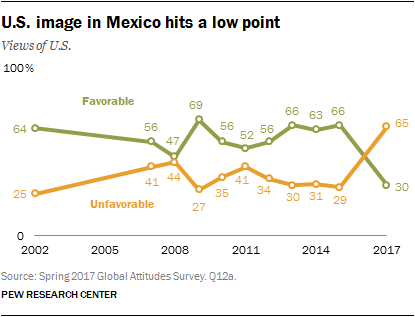What does the source tell us about this data, and how might this affect our interpretation? The source, which is the Spring 2017 Global Attitudes Survey by Pew Research Center, suggests that the data is collected through a survey method which captures the attitudes of a sample of the Mexican population at a specific point in time. However, the way questions are phrased, the sampling methodology, and the timing of the survey might affect our interpretation. It's important to consider these factors for contextual accuracy and acknowledge that the data represents a snapshot of opinions that may have fluctuated before or after the survey was conducted. 